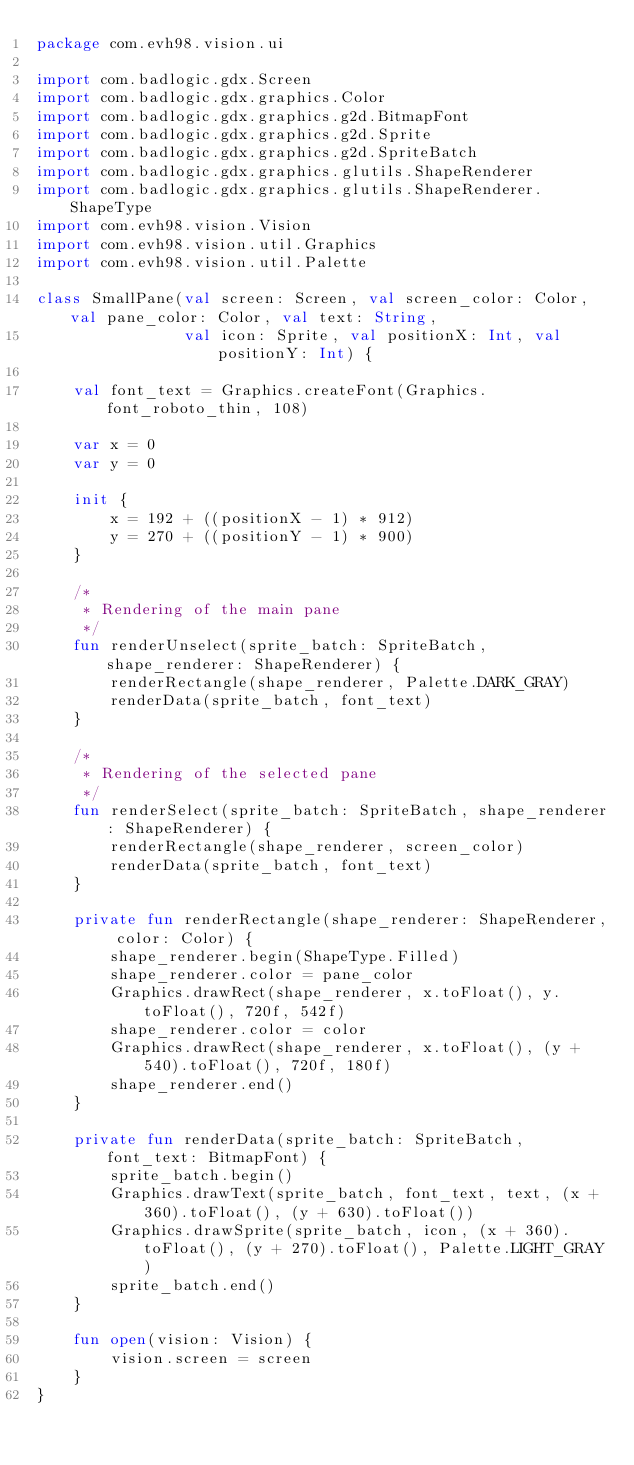<code> <loc_0><loc_0><loc_500><loc_500><_Kotlin_>package com.evh98.vision.ui

import com.badlogic.gdx.Screen
import com.badlogic.gdx.graphics.Color
import com.badlogic.gdx.graphics.g2d.BitmapFont
import com.badlogic.gdx.graphics.g2d.Sprite
import com.badlogic.gdx.graphics.g2d.SpriteBatch
import com.badlogic.gdx.graphics.glutils.ShapeRenderer
import com.badlogic.gdx.graphics.glutils.ShapeRenderer.ShapeType
import com.evh98.vision.Vision
import com.evh98.vision.util.Graphics
import com.evh98.vision.util.Palette

class SmallPane(val screen: Screen, val screen_color: Color, val pane_color: Color, val text: String,
                val icon: Sprite, val positionX: Int, val positionY: Int) {

    val font_text = Graphics.createFont(Graphics.font_roboto_thin, 108)

    var x = 0
    var y = 0

    init {
        x = 192 + ((positionX - 1) * 912)
        y = 270 + ((positionY - 1) * 900)
    }

    /*
	 * Rendering of the main pane
	 */
    fun renderUnselect(sprite_batch: SpriteBatch, shape_renderer: ShapeRenderer) {
        renderRectangle(shape_renderer, Palette.DARK_GRAY)
        renderData(sprite_batch, font_text)
    }

    /*
	 * Rendering of the selected pane
	 */
    fun renderSelect(sprite_batch: SpriteBatch, shape_renderer: ShapeRenderer) {
        renderRectangle(shape_renderer, screen_color)
        renderData(sprite_batch, font_text)
    }

    private fun renderRectangle(shape_renderer: ShapeRenderer, color: Color) {
        shape_renderer.begin(ShapeType.Filled)
        shape_renderer.color = pane_color
        Graphics.drawRect(shape_renderer, x.toFloat(), y.toFloat(), 720f, 542f)
        shape_renderer.color = color
        Graphics.drawRect(shape_renderer, x.toFloat(), (y + 540).toFloat(), 720f, 180f)
        shape_renderer.end()
    }

    private fun renderData(sprite_batch: SpriteBatch, font_text: BitmapFont) {
        sprite_batch.begin()
        Graphics.drawText(sprite_batch, font_text, text, (x + 360).toFloat(), (y + 630).toFloat())
        Graphics.drawSprite(sprite_batch, icon, (x + 360).toFloat(), (y + 270).toFloat(), Palette.LIGHT_GRAY)
        sprite_batch.end()
    }

    fun open(vision: Vision) {
        vision.screen = screen
    }
}
</code> 